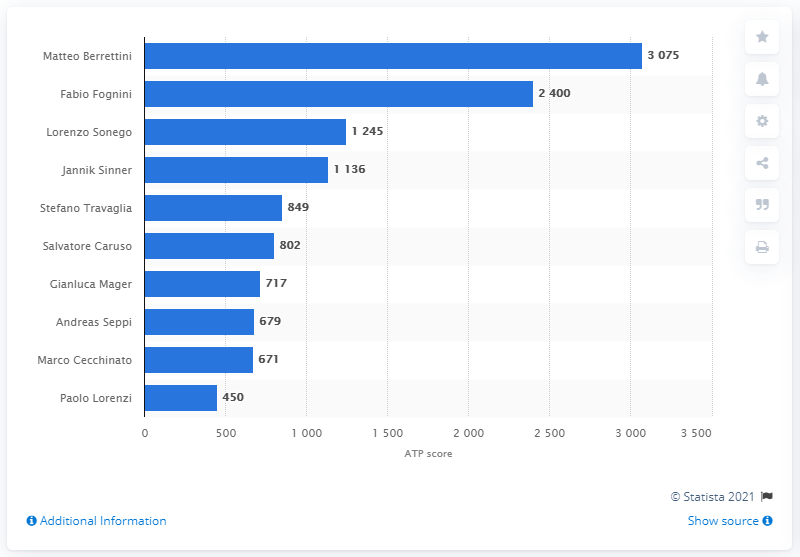Indicate a few pertinent items in this graphic. Matteo Berrettini is the Italian tennis player who has earned the highest number of ATP ranking points as of October 12, 2020. Fabio Fognini is the person who scored 2,400 ranking points as of October 12, 2020. 